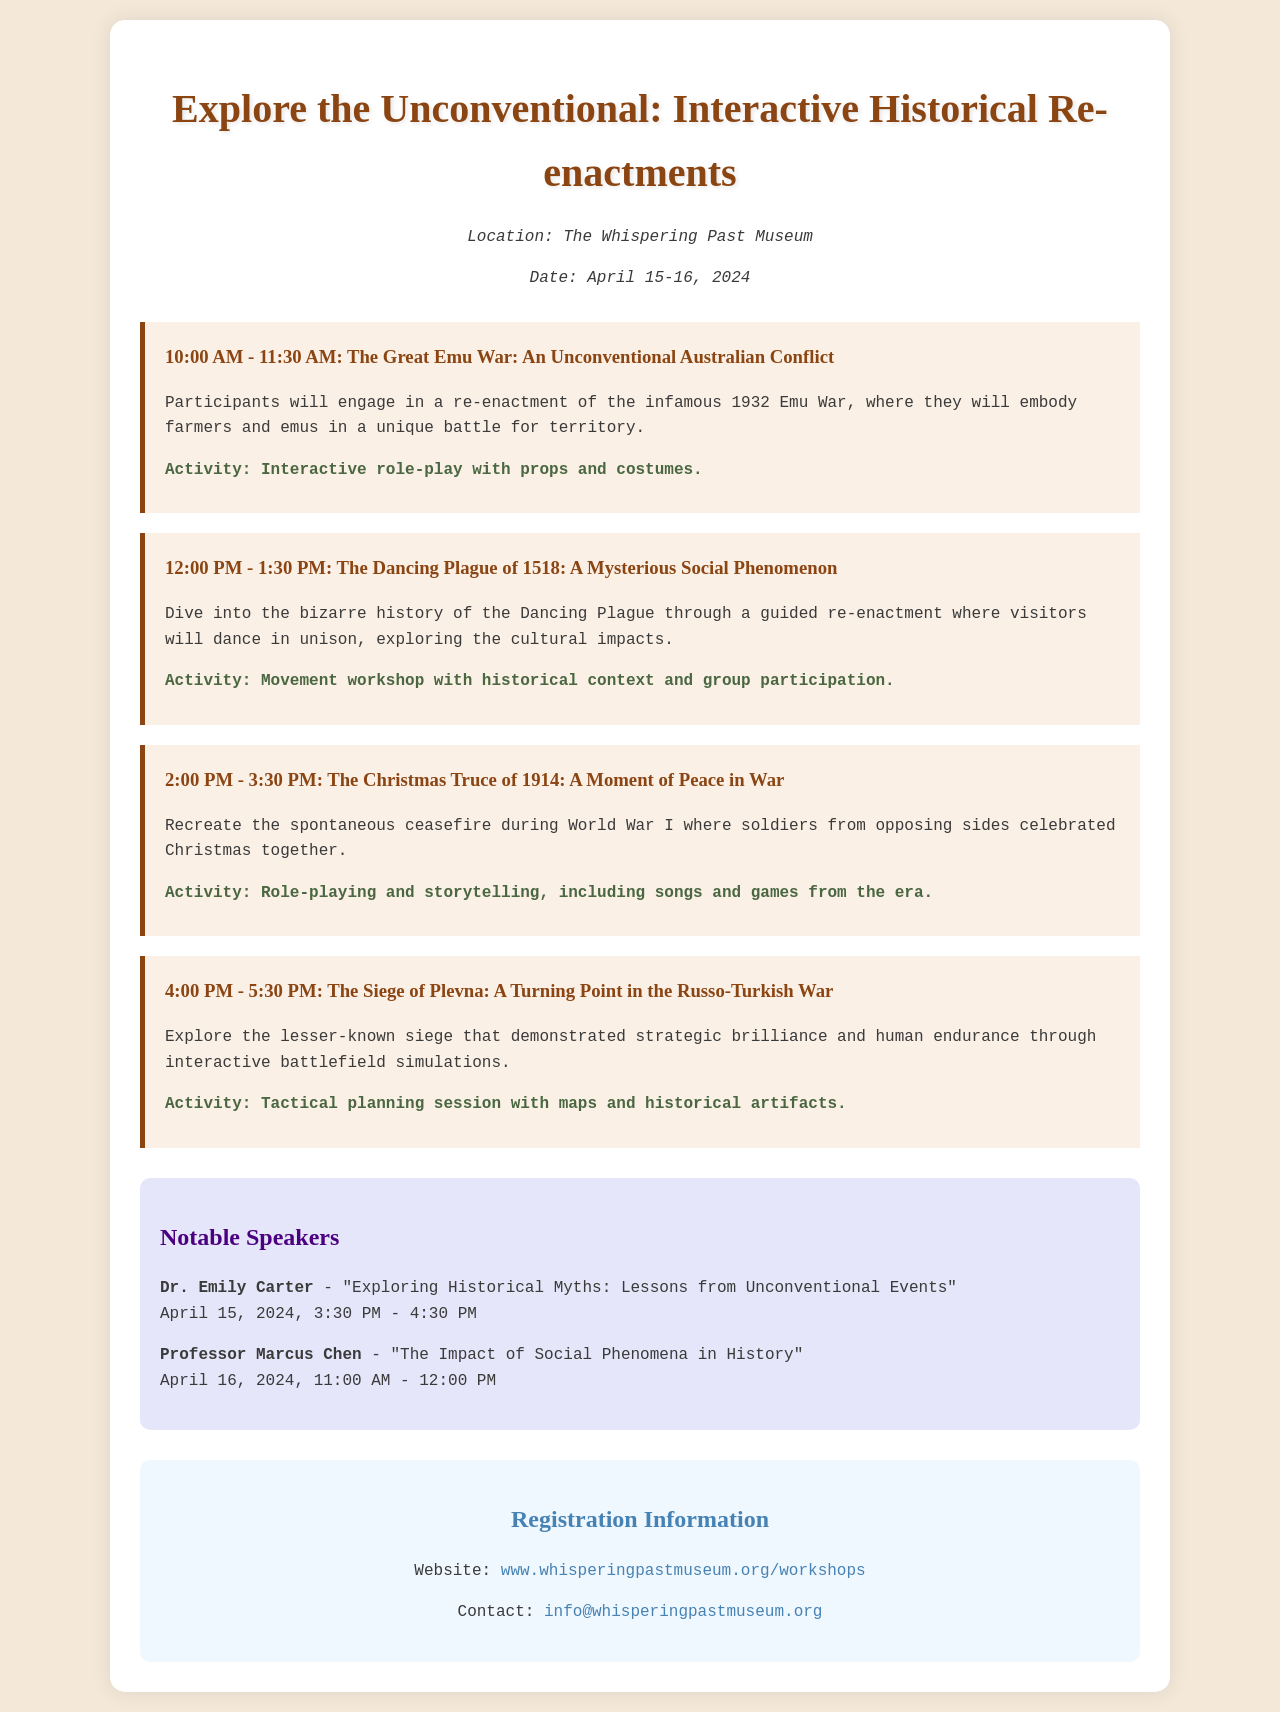What is the location of the event? The location is specified in the document under header info, stating the venue for the workshop.
Answer: The Whispering Past Museum What are the dates of the workshop? The dates are mentioned in the header info section, providing the schedule for the activity.
Answer: April 15-16, 2024 What time does the session on the Christmas Truce of 1914 start? The start time for this session is indicated in the schedule of sessions listed in the document.
Answer: 2:00 PM Who is the speaker discussing historical myths? The document lists notable speakers along with their topics, indicating the individual presenting on this theme.
Answer: Dr. Emily Carter What interactive activity is part of the Dancing Plague session? The document outlines the activities associated with each session, detailing the type of engagement for visitors.
Answer: Movement workshop with historical context and group participation How long is each session in the schedule? The duration of each session is uniform across the schedule, as shown in the times indicated for each event.
Answer: 1.5 hours What is the title of the session on the Siege of Plevna? The title of the session is included in the description of the interactive re-enactment events in the schedule.
Answer: The Siege of Plevna: A Turning Point in the Russo-Turkish War What type of workshop is centered around the Emu War? The document describes the nature of this workshop in the context of its session content and activities.
Answer: Interactive role-play with props and costumes 